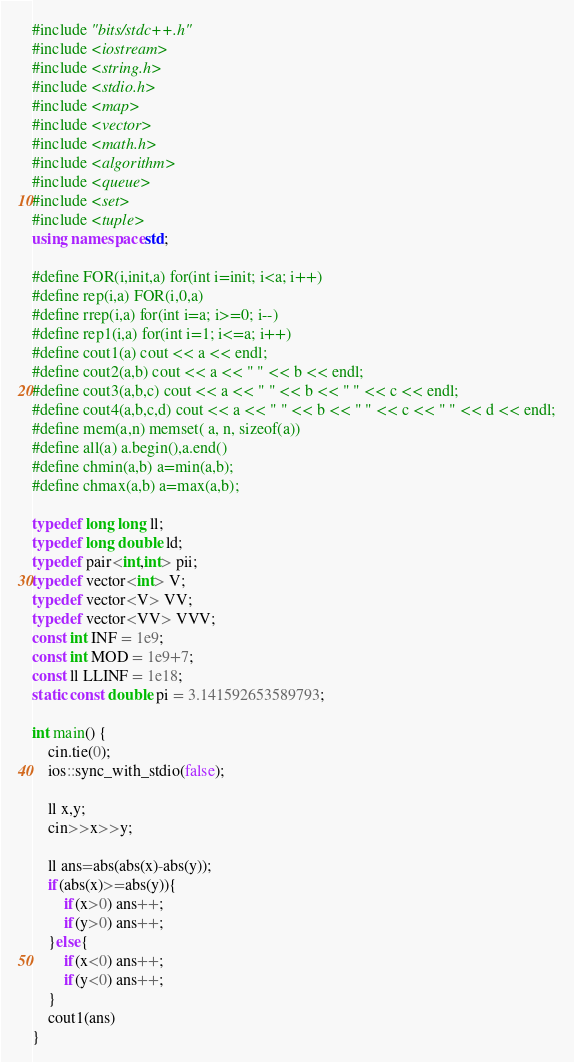Convert code to text. <code><loc_0><loc_0><loc_500><loc_500><_C++_>#include "bits/stdc++.h"
#include <iostream>
#include <string.h>
#include <stdio.h>
#include <map>
#include <vector>
#include <math.h>
#include <algorithm>
#include <queue>
#include <set>
#include <tuple>
using namespace std;

#define FOR(i,init,a) for(int i=init; i<a; i++)
#define rep(i,a) FOR(i,0,a)
#define rrep(i,a) for(int i=a; i>=0; i--)
#define rep1(i,a) for(int i=1; i<=a; i++)
#define cout1(a) cout << a << endl;
#define cout2(a,b) cout << a << " " << b << endl;
#define cout3(a,b,c) cout << a << " " << b << " " << c << endl;
#define cout4(a,b,c,d) cout << a << " " << b << " " << c << " " << d << endl;
#define mem(a,n) memset( a, n, sizeof(a))
#define all(a) a.begin(),a.end()
#define chmin(a,b) a=min(a,b);
#define chmax(a,b) a=max(a,b);

typedef long long ll;
typedef long double ld;
typedef pair<int,int> pii;
typedef vector<int> V;
typedef vector<V> VV;
typedef vector<VV> VVV;
const int INF = 1e9;
const int MOD = 1e9+7;
const ll LLINF = 1e18;
static const double pi = 3.141592653589793;

int main() {
    cin.tie(0);
    ios::sync_with_stdio(false);
    
    ll x,y;
    cin>>x>>y;
    
    ll ans=abs(abs(x)-abs(y));
    if(abs(x)>=abs(y)){
        if(x>0) ans++;
        if(y>0) ans++;
    }else{
        if(x<0) ans++;
        if(y<0) ans++;
    }
    cout1(ans)
}</code> 